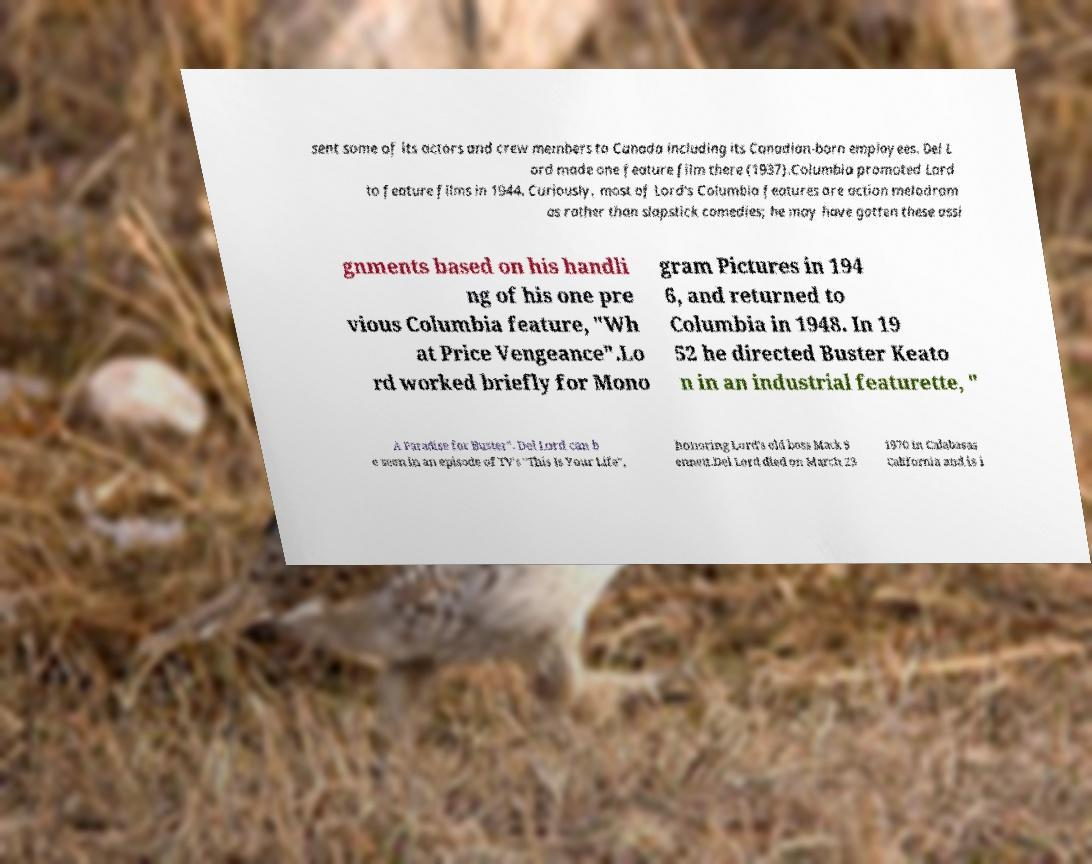I need the written content from this picture converted into text. Can you do that? sent some of its actors and crew members to Canada including its Canadian-born employees. Del L ord made one feature film there (1937).Columbia promoted Lord to feature films in 1944. Curiously, most of Lord's Columbia features are action melodram as rather than slapstick comedies; he may have gotten these assi gnments based on his handli ng of his one pre vious Columbia feature, "Wh at Price Vengeance".Lo rd worked briefly for Mono gram Pictures in 194 6, and returned to Columbia in 1948. In 19 52 he directed Buster Keato n in an industrial featurette, " A Paradise for Buster". Del Lord can b e seen in an episode of TV's "This Is Your Life", honoring Lord's old boss Mack S ennett.Del Lord died on March 23 1970 in Calabasas California and is i 